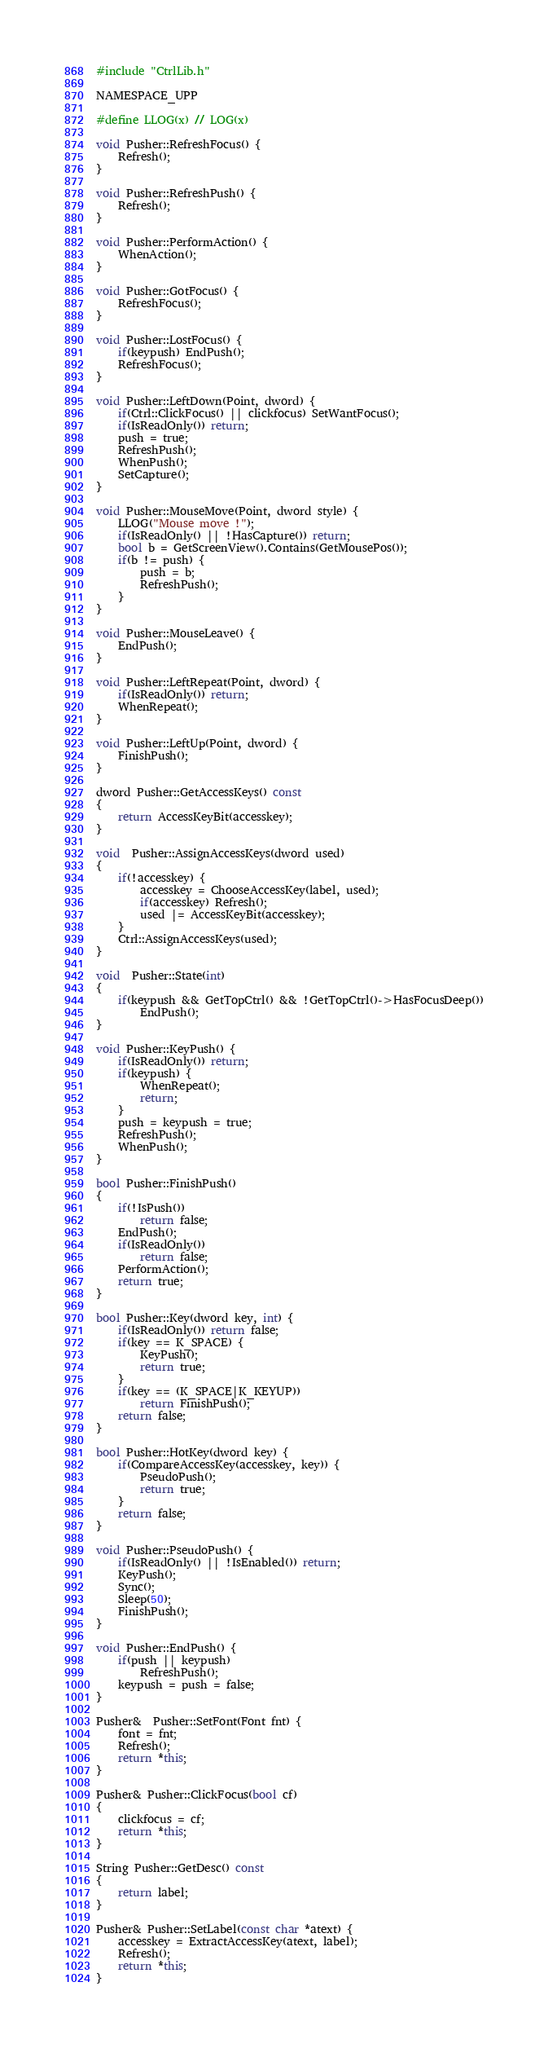<code> <loc_0><loc_0><loc_500><loc_500><_C++_>#include "CtrlLib.h"

NAMESPACE_UPP

#define LLOG(x) // LOG(x)

void Pusher::RefreshFocus() {
	Refresh();
}

void Pusher::RefreshPush() {
	Refresh();
}

void Pusher::PerformAction() {
	WhenAction();
}

void Pusher::GotFocus() {
	RefreshFocus();
}

void Pusher::LostFocus() {
	if(keypush) EndPush();
	RefreshFocus();
}

void Pusher::LeftDown(Point, dword) {
	if(Ctrl::ClickFocus() || clickfocus) SetWantFocus();
	if(IsReadOnly()) return;
	push = true;
	RefreshPush();
	WhenPush();
	SetCapture();
}

void Pusher::MouseMove(Point, dword style) {
	LLOG("Mouse move !");
	if(IsReadOnly() || !HasCapture()) return;
	bool b = GetScreenView().Contains(GetMousePos());
	if(b != push) {
		push = b;
		RefreshPush();
	}
}

void Pusher::MouseLeave() {
	EndPush();
}

void Pusher::LeftRepeat(Point, dword) {
	if(IsReadOnly()) return;
	WhenRepeat();
}

void Pusher::LeftUp(Point, dword) {
	FinishPush();
}

dword Pusher::GetAccessKeys() const
{
	return AccessKeyBit(accesskey);
}

void  Pusher::AssignAccessKeys(dword used)
{
	if(!accesskey) {
		accesskey = ChooseAccessKey(label, used);
		if(accesskey) Refresh();
		used |= AccessKeyBit(accesskey);
	}
	Ctrl::AssignAccessKeys(used);
}

void  Pusher::State(int)
{
	if(keypush && GetTopCtrl() && !GetTopCtrl()->HasFocusDeep())
		EndPush();
}

void Pusher::KeyPush() {
	if(IsReadOnly()) return;
	if(keypush) {
		WhenRepeat();
		return;
	}
	push = keypush = true;
	RefreshPush();
	WhenPush();
}

bool Pusher::FinishPush()
{
	if(!IsPush())
		return false;
	EndPush();
	if(IsReadOnly())
		return false;
	PerformAction();
	return true;
}

bool Pusher::Key(dword key, int) {
	if(IsReadOnly()) return false;
	if(key == K_SPACE) {
		KeyPush();
		return true;
	}
	if(key == (K_SPACE|K_KEYUP))
		return FinishPush();
	return false;
}

bool Pusher::HotKey(dword key) {
	if(CompareAccessKey(accesskey, key)) {
		PseudoPush();
		return true;
	}
	return false;
}

void Pusher::PseudoPush() {
	if(IsReadOnly() || !IsEnabled()) return;
	KeyPush();
	Sync();
	Sleep(50);
	FinishPush();
}

void Pusher::EndPush() {
	if(push || keypush)
		RefreshPush();
	keypush = push = false;
}

Pusher&  Pusher::SetFont(Font fnt) {
	font = fnt;
	Refresh();
	return *this;
}

Pusher& Pusher::ClickFocus(bool cf)
{
	clickfocus = cf;
	return *this;
}

String Pusher::GetDesc() const
{
	return label;
}

Pusher& Pusher::SetLabel(const char *atext) {
	accesskey = ExtractAccessKey(atext, label);
	Refresh();
	return *this;
}
</code> 